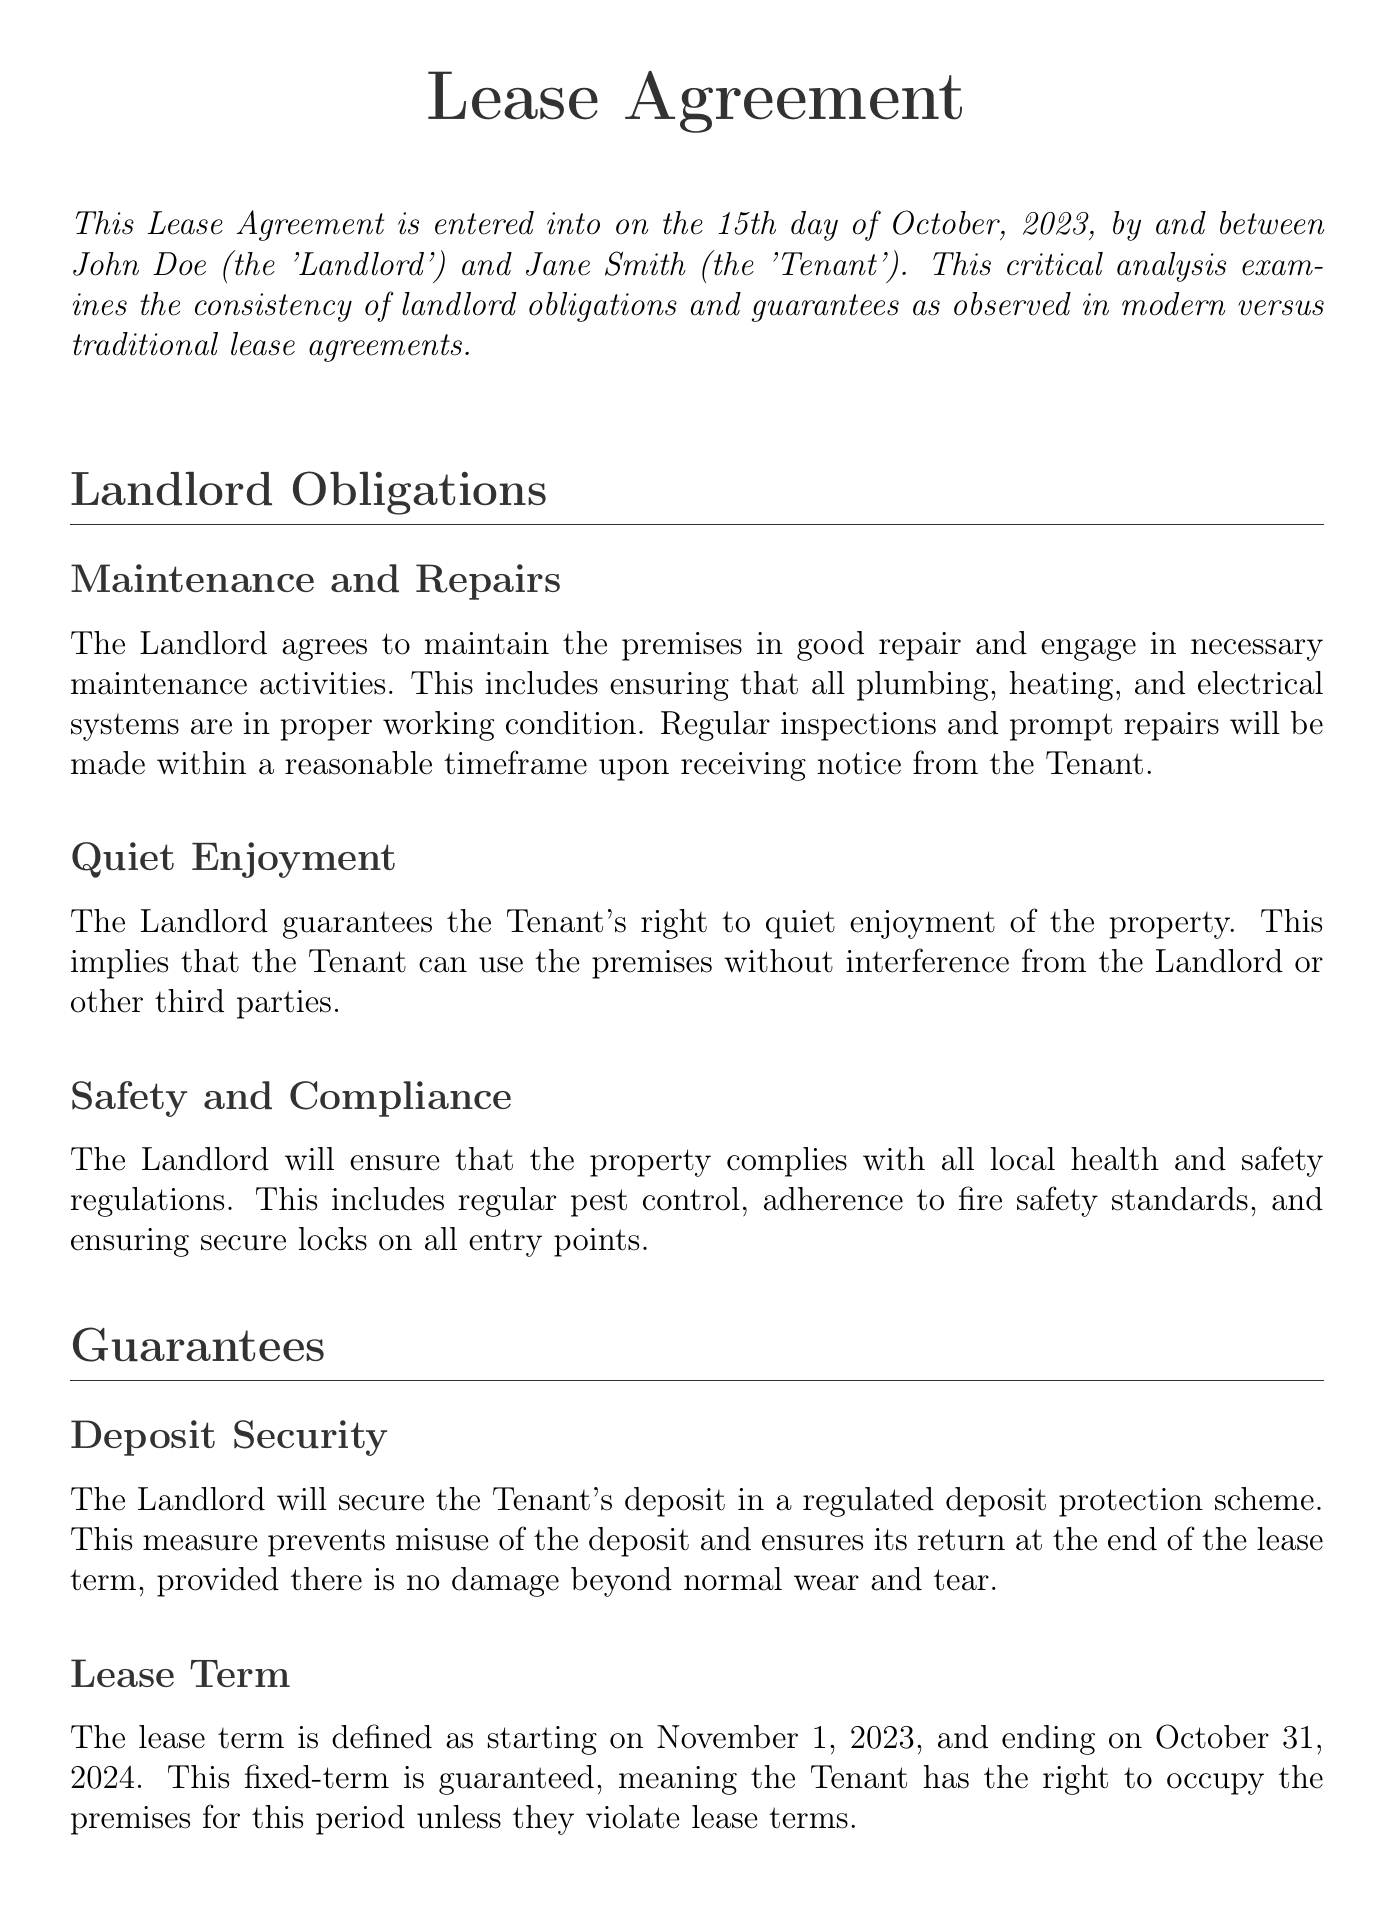What is the name of the Landlord? The document explicitly states the name of the Landlord as John Doe.
Answer: John Doe What is the start date of the lease term? The lease term is defined to start on the 1st of November, 2023, as mentioned in the document.
Answer: November 1, 2023 What obligation does the Landlord have regarding safety? The Landlord ensures compliance with local health and safety regulations, as outlined in the obligations section.
Answer: Safety and Compliance How long is the lease term? The lease term is stated to last for one year, from the start date to the end date mentioned in the document.
Answer: One year What is the Tenant's right related to the property use? The Landlord guarantees the Tenant's right to quiet enjoyment, allowing use without interference.
Answer: Quiet Enjoyment What does the Landlord agree to in case of disputes? The Landlord agrees to a formal dispute resolution process, providing a structured channel for issues.
Answer: Dispute Resolution What type of protection scheme secures the deposit? According to the guarantees section, the deposit is secured in a regulated deposit protection scheme.
Answer: Regulated deposit protection scheme What is the name of the Tenant? The Tenant's name is explicitly stated in the document as Jane Smith.
Answer: Jane Smith What must the Tenant do to secure the return of the deposit? The document specifies that the return of the deposit is contingent on no damage beyond normal wear and tear.
Answer: Normal wear and tear 